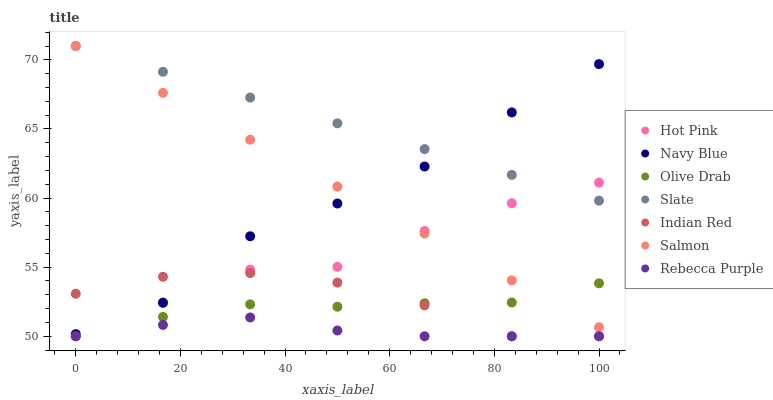Does Rebecca Purple have the minimum area under the curve?
Answer yes or no. Yes. Does Slate have the maximum area under the curve?
Answer yes or no. Yes. Does Hot Pink have the minimum area under the curve?
Answer yes or no. No. Does Hot Pink have the maximum area under the curve?
Answer yes or no. No. Is Salmon the smoothest?
Answer yes or no. Yes. Is Navy Blue the roughest?
Answer yes or no. Yes. Is Slate the smoothest?
Answer yes or no. No. Is Slate the roughest?
Answer yes or no. No. Does Hot Pink have the lowest value?
Answer yes or no. Yes. Does Slate have the lowest value?
Answer yes or no. No. Does Salmon have the highest value?
Answer yes or no. Yes. Does Hot Pink have the highest value?
Answer yes or no. No. Is Olive Drab less than Navy Blue?
Answer yes or no. Yes. Is Navy Blue greater than Olive Drab?
Answer yes or no. Yes. Does Indian Red intersect Rebecca Purple?
Answer yes or no. Yes. Is Indian Red less than Rebecca Purple?
Answer yes or no. No. Is Indian Red greater than Rebecca Purple?
Answer yes or no. No. Does Olive Drab intersect Navy Blue?
Answer yes or no. No. 